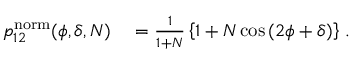<formula> <loc_0><loc_0><loc_500><loc_500>\begin{array} { r l } { p _ { 1 2 } ^ { n o r m } ( \phi , \delta , N ) } & = \frac { 1 } { 1 + N } \left \{ 1 + N \cos \left ( 2 \phi + \delta \right ) \right \} \, . } \end{array}</formula> 